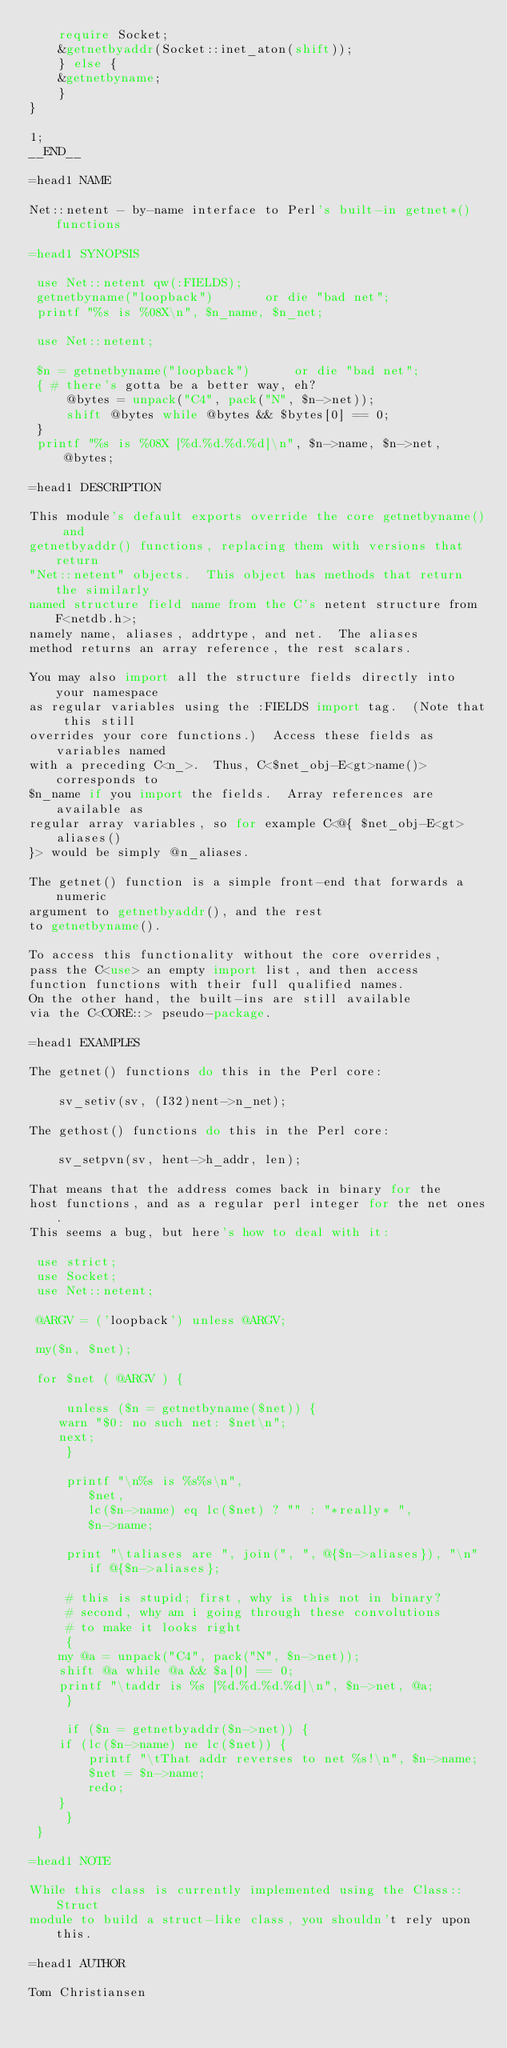<code> <loc_0><loc_0><loc_500><loc_500><_Perl_>	require Socket;
	&getnetbyaddr(Socket::inet_aton(shift));
    } else {
	&getnetbyname;
    } 
} 

1;
__END__

=head1 NAME

Net::netent - by-name interface to Perl's built-in getnet*() functions

=head1 SYNOPSIS

 use Net::netent qw(:FIELDS);
 getnetbyname("loopback") 		or die "bad net";
 printf "%s is %08X\n", $n_name, $n_net;

 use Net::netent;

 $n = getnetbyname("loopback") 		or die "bad net";
 { # there's gotta be a better way, eh?
     @bytes = unpack("C4", pack("N", $n->net));
     shift @bytes while @bytes && $bytes[0] == 0;
 }
 printf "%s is %08X [%d.%d.%d.%d]\n", $n->name, $n->net, @bytes;

=head1 DESCRIPTION

This module's default exports override the core getnetbyname() and
getnetbyaddr() functions, replacing them with versions that return
"Net::netent" objects.  This object has methods that return the similarly
named structure field name from the C's netent structure from F<netdb.h>;
namely name, aliases, addrtype, and net.  The aliases 
method returns an array reference, the rest scalars.  

You may also import all the structure fields directly into your namespace
as regular variables using the :FIELDS import tag.  (Note that this still
overrides your core functions.)  Access these fields as variables named
with a preceding C<n_>.  Thus, C<$net_obj-E<gt>name()> corresponds to
$n_name if you import the fields.  Array references are available as
regular array variables, so for example C<@{ $net_obj-E<gt>aliases()
}> would be simply @n_aliases.

The getnet() function is a simple front-end that forwards a numeric
argument to getnetbyaddr(), and the rest
to getnetbyname().

To access this functionality without the core overrides,
pass the C<use> an empty import list, and then access
function functions with their full qualified names.
On the other hand, the built-ins are still available
via the C<CORE::> pseudo-package.

=head1 EXAMPLES

The getnet() functions do this in the Perl core:

    sv_setiv(sv, (I32)nent->n_net);

The gethost() functions do this in the Perl core:

    sv_setpvn(sv, hent->h_addr, len);

That means that the address comes back in binary for the
host functions, and as a regular perl integer for the net ones.
This seems a bug, but here's how to deal with it:

 use strict;
 use Socket;
 use Net::netent;

 @ARGV = ('loopback') unless @ARGV;

 my($n, $net);

 for $net ( @ARGV ) {

     unless ($n = getnetbyname($net)) {
 	warn "$0: no such net: $net\n";
 	next;
     }

     printf "\n%s is %s%s\n", 
 	    $net, 
 	    lc($n->name) eq lc($net) ? "" : "*really* ",
 	    $n->name;

     print "\taliases are ", join(", ", @{$n->aliases}), "\n"
 		if @{$n->aliases};     

     # this is stupid; first, why is this not in binary?
     # second, why am i going through these convolutions
     # to make it looks right
     {
 	my @a = unpack("C4", pack("N", $n->net));
 	shift @a while @a && $a[0] == 0;
 	printf "\taddr is %s [%d.%d.%d.%d]\n", $n->net, @a;
     }

     if ($n = getnetbyaddr($n->net)) {
 	if (lc($n->name) ne lc($net)) {
 	    printf "\tThat addr reverses to net %s!\n", $n->name;
 	    $net = $n->name;
 	    redo;
 	} 
     }
 }

=head1 NOTE

While this class is currently implemented using the Class::Struct
module to build a struct-like class, you shouldn't rely upon this.

=head1 AUTHOR

Tom Christiansen
</code> 